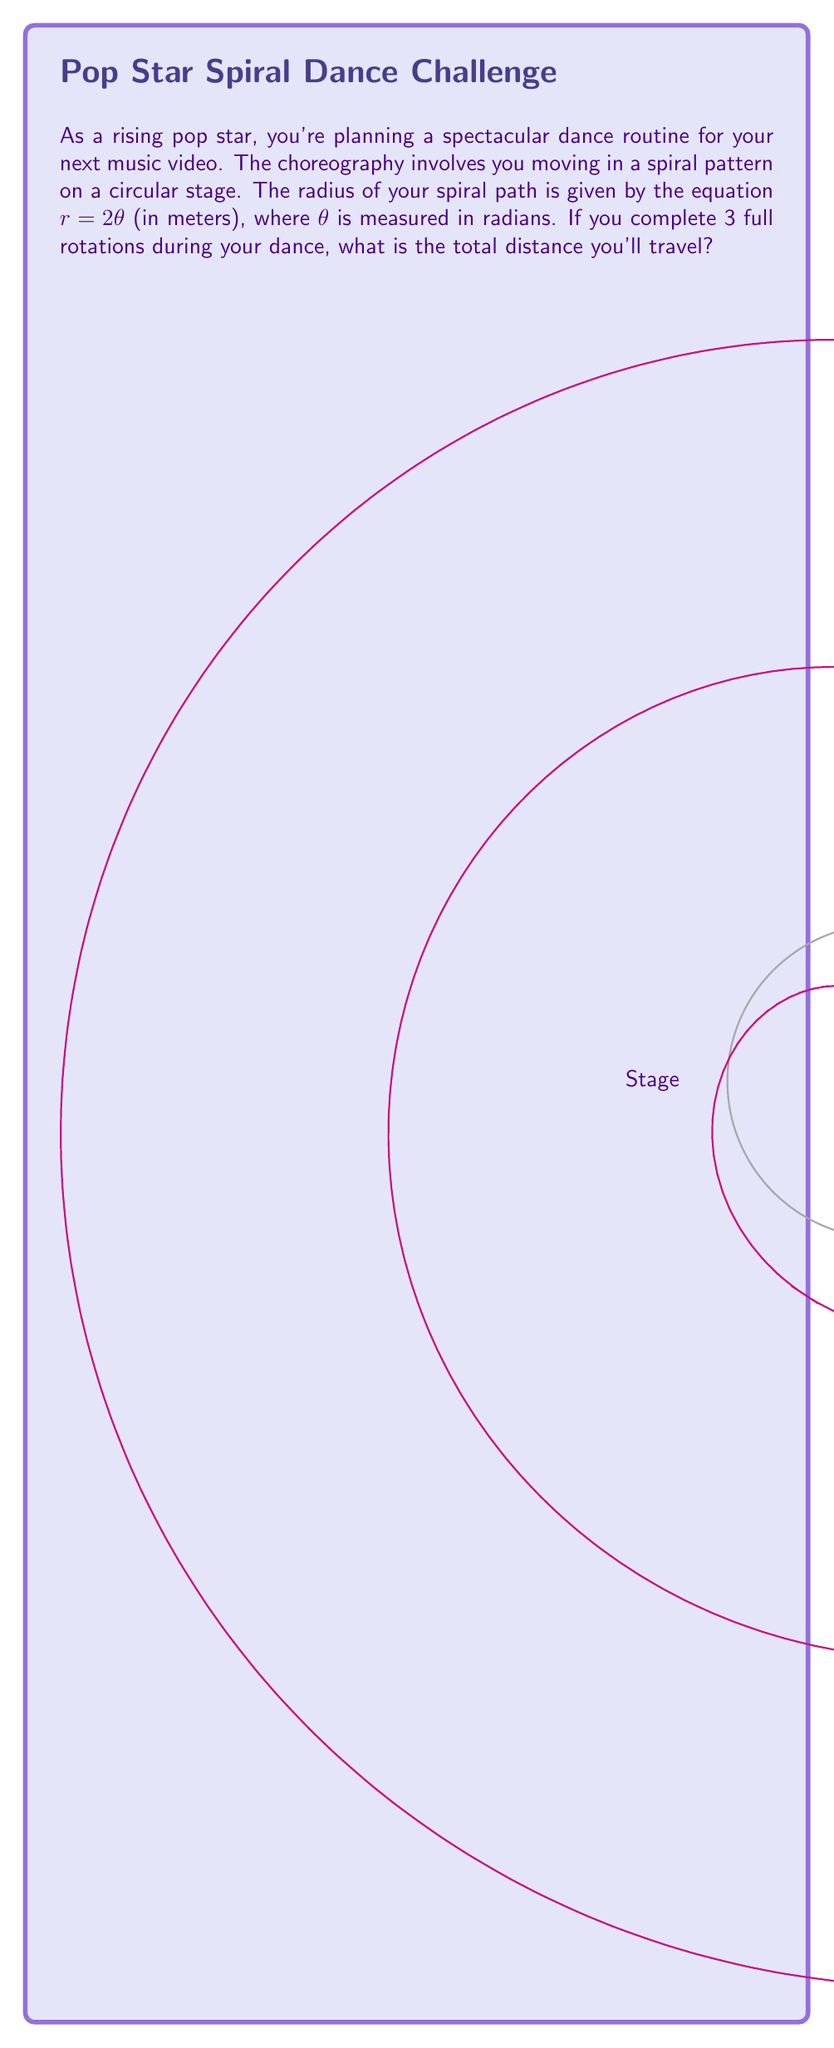What is the answer to this math problem? Let's approach this step-by-step:

1) The spiral path is given by $r = 2\theta$ in polar coordinates.

2) To find the total distance, we need to use the arc length formula for polar curves:

   $$L = \int_a^b \sqrt{r^2 + \left(\frac{dr}{d\theta}\right)^2} d\theta$$

3) In our case:
   $r = 2\theta$
   $\frac{dr}{d\theta} = 2$

4) Substituting into the formula:

   $$L = \int_0^{6\pi} \sqrt{(2\theta)^2 + 2^2} d\theta$$

5) Simplify under the square root:

   $$L = \int_0^{6\pi} \sqrt{4\theta^2 + 4} d\theta$$

6) Factor out 4:

   $$L = 2\int_0^{6\pi} \sqrt{\theta^2 + 1} d\theta$$

7) This integral doesn't have an elementary antiderivative. We need to use the hyperbolic functions:

   $$L = 2[\theta \sqrt{\theta^2 + 1} + \sinh^{-1}(\theta)]_0^{6\pi}$$

8) Evaluate at the limits:

   $$L = 2[(6\pi \sqrt{36\pi^2 + 1} + \sinh^{-1}(6\pi)) - (0 \sqrt{0^2 + 1} + \sinh^{-1}(0))]$$

9) Simplify:

   $$L = 2[6\pi \sqrt{36\pi^2 + 1} + \sinh^{-1}(6\pi)]$$

10) Calculate the numerical value (rounded to two decimal places):

    $$L \approx 226.19 \text{ meters}$$
Answer: $226.19$ meters 